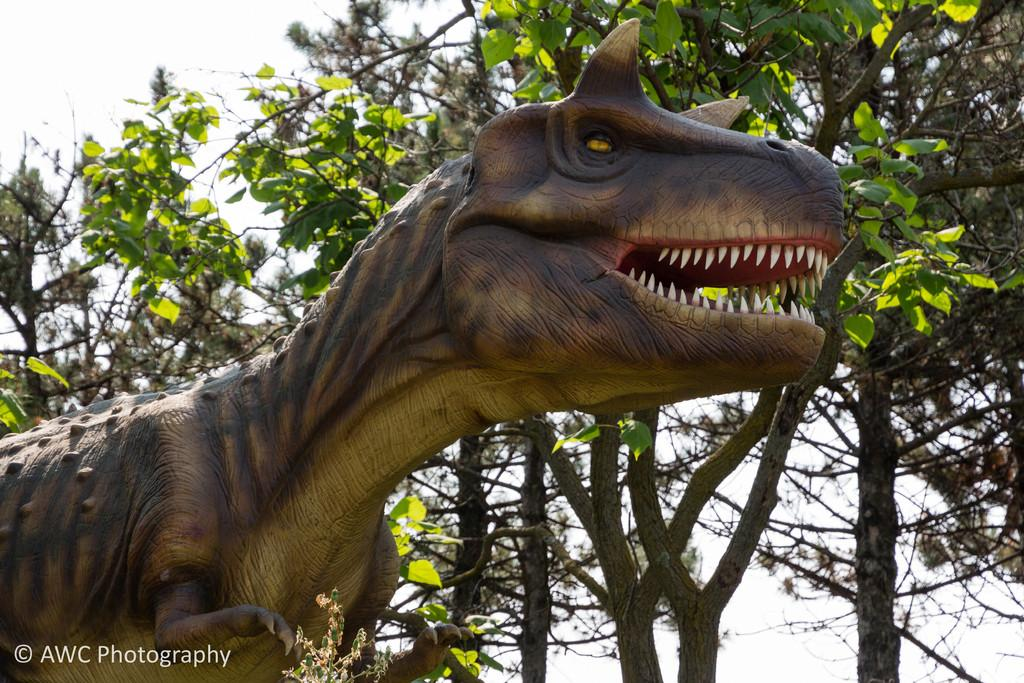What can be found in the bottom left-hand side of the image? There is a watermark in the bottom left-hand side of the image. What is the main subject in the middle of the image? There is a doll in the shape of an animal in the middle of the image. What type of natural environment is visible in the image? There are trees visible in the image. What is visible at the top of the image? The sky is visible at the top of the image. What type of quince is being used as a prop in the image? There is no quince present in the image. How many properties are visible in the image? The image does not depict any properties; it features a doll, trees, and a sky. 